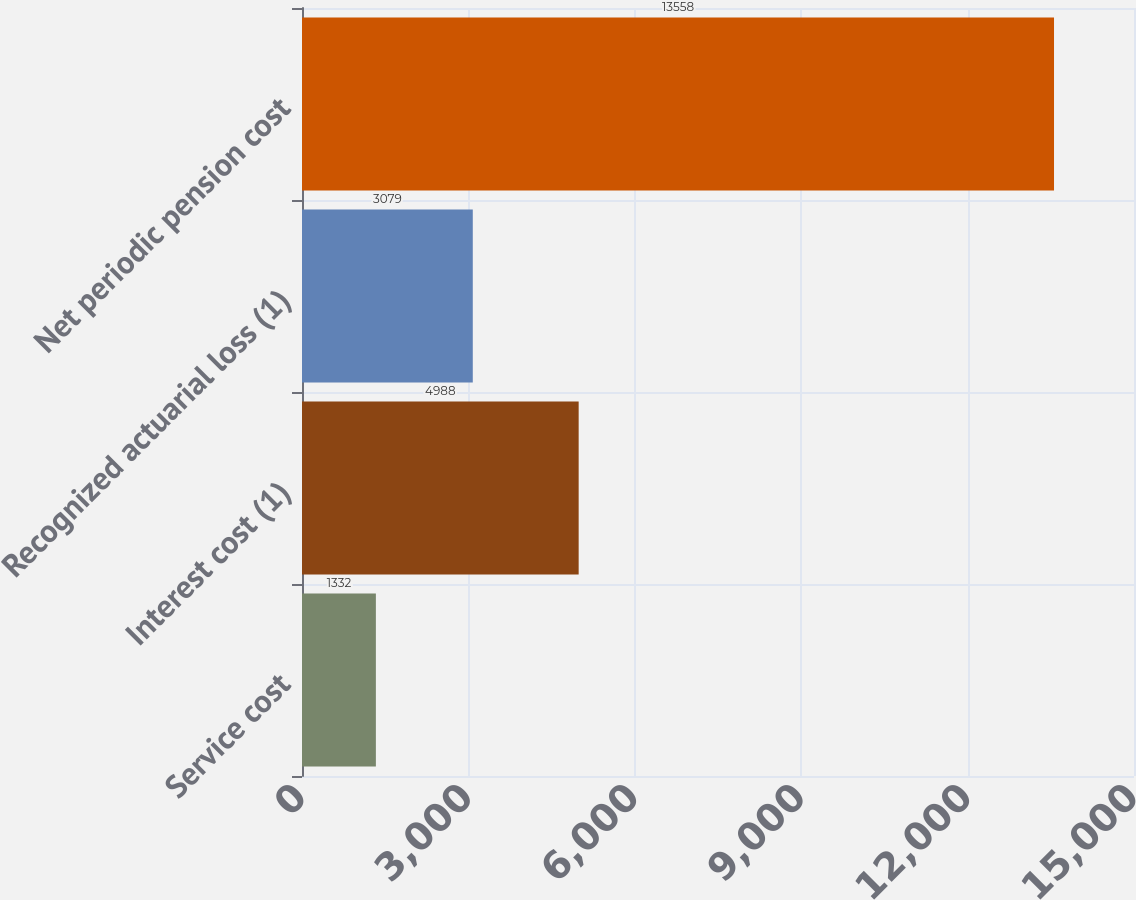Convert chart to OTSL. <chart><loc_0><loc_0><loc_500><loc_500><bar_chart><fcel>Service cost<fcel>Interest cost (1)<fcel>Recognized actuarial loss (1)<fcel>Net periodic pension cost<nl><fcel>1332<fcel>4988<fcel>3079<fcel>13558<nl></chart> 